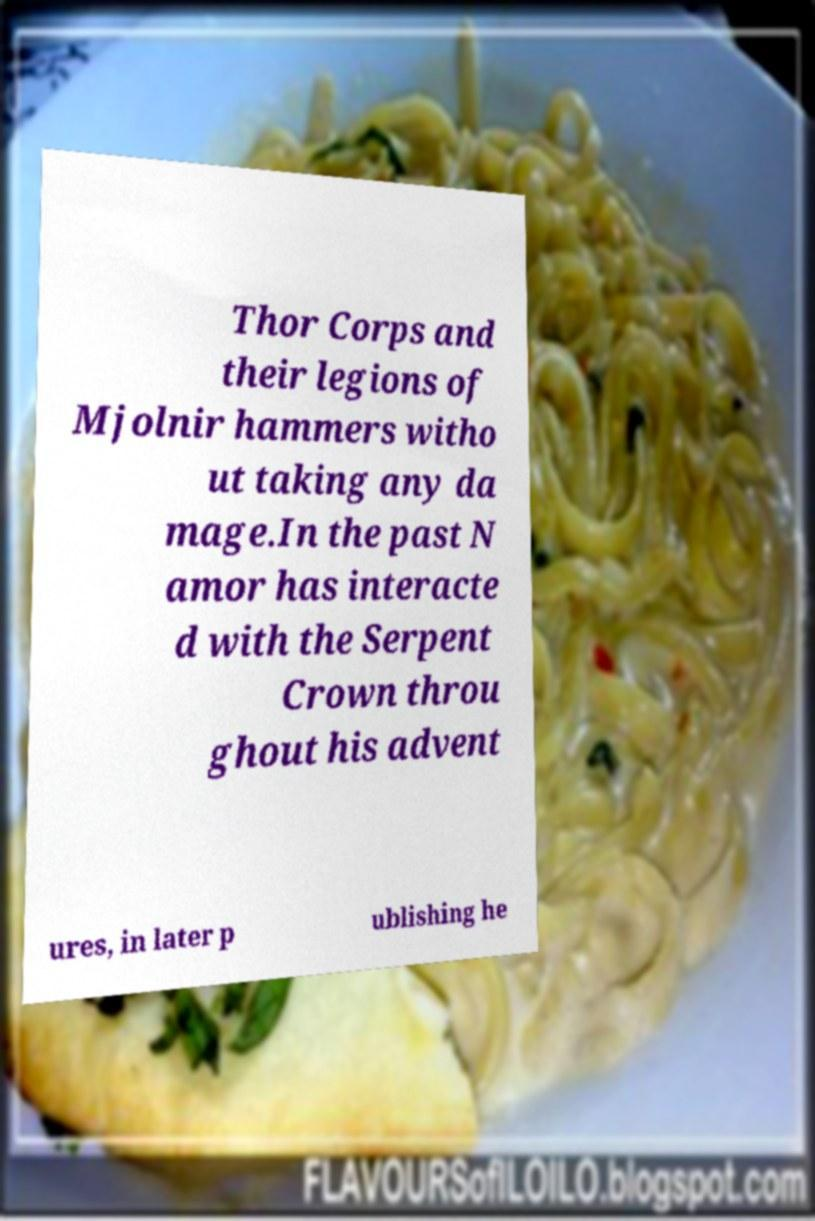I need the written content from this picture converted into text. Can you do that? Thor Corps and their legions of Mjolnir hammers witho ut taking any da mage.In the past N amor has interacte d with the Serpent Crown throu ghout his advent ures, in later p ublishing he 